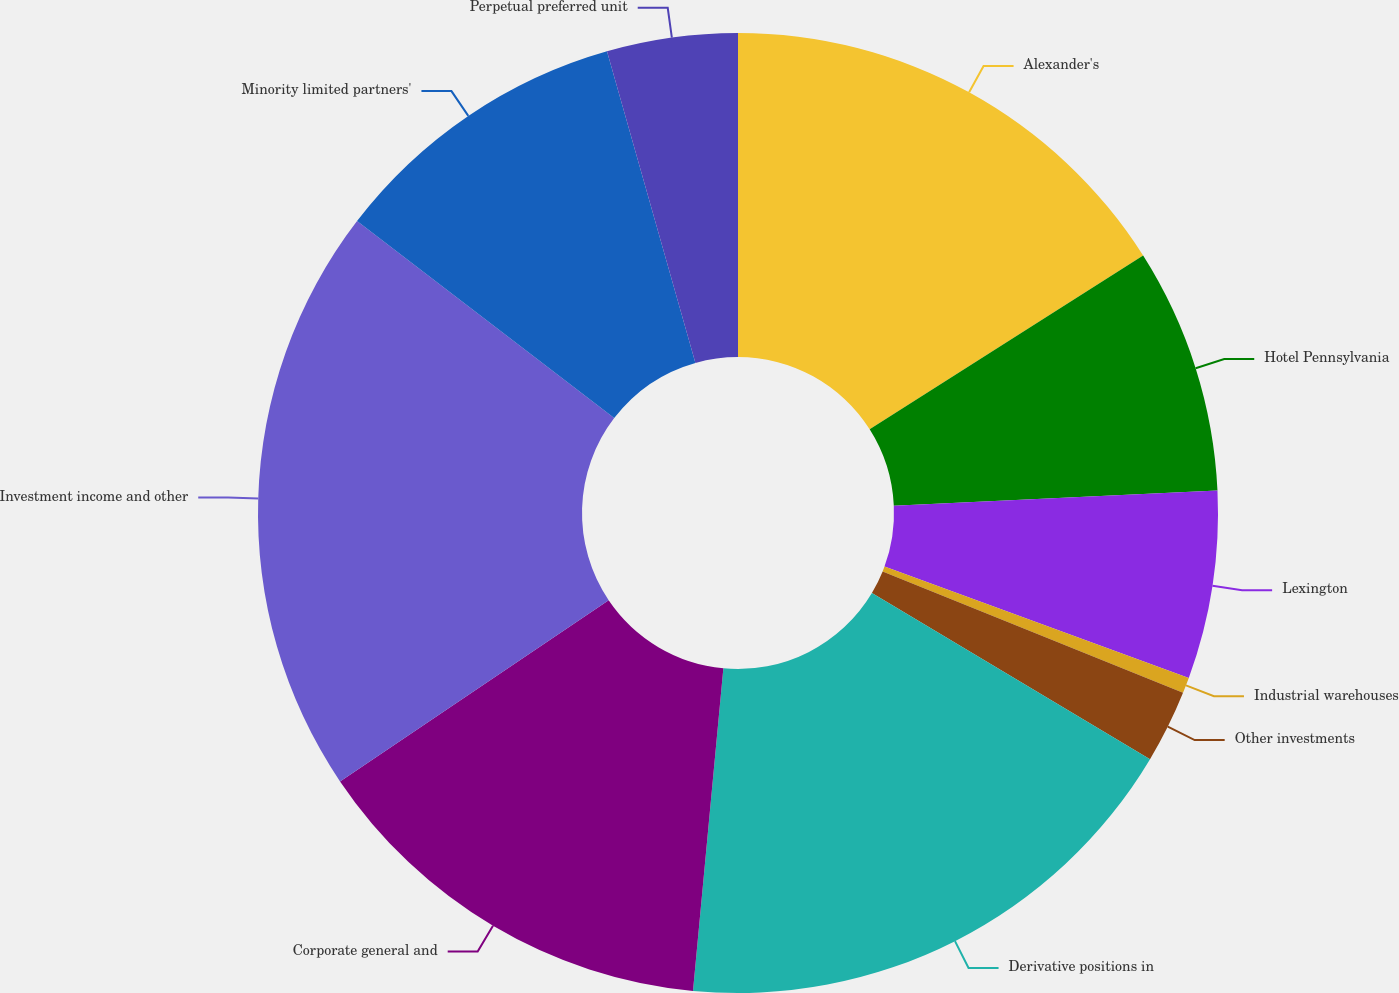Convert chart. <chart><loc_0><loc_0><loc_500><loc_500><pie_chart><fcel>Alexander's<fcel>Hotel Pennsylvania<fcel>Lexington<fcel>Industrial warehouses<fcel>Other investments<fcel>Derivative positions in<fcel>Corporate general and<fcel>Investment income and other<fcel>Minority limited partners'<fcel>Perpetual preferred unit<nl><fcel>15.99%<fcel>8.26%<fcel>6.33%<fcel>0.53%<fcel>2.46%<fcel>17.92%<fcel>14.06%<fcel>19.85%<fcel>10.19%<fcel>4.4%<nl></chart> 